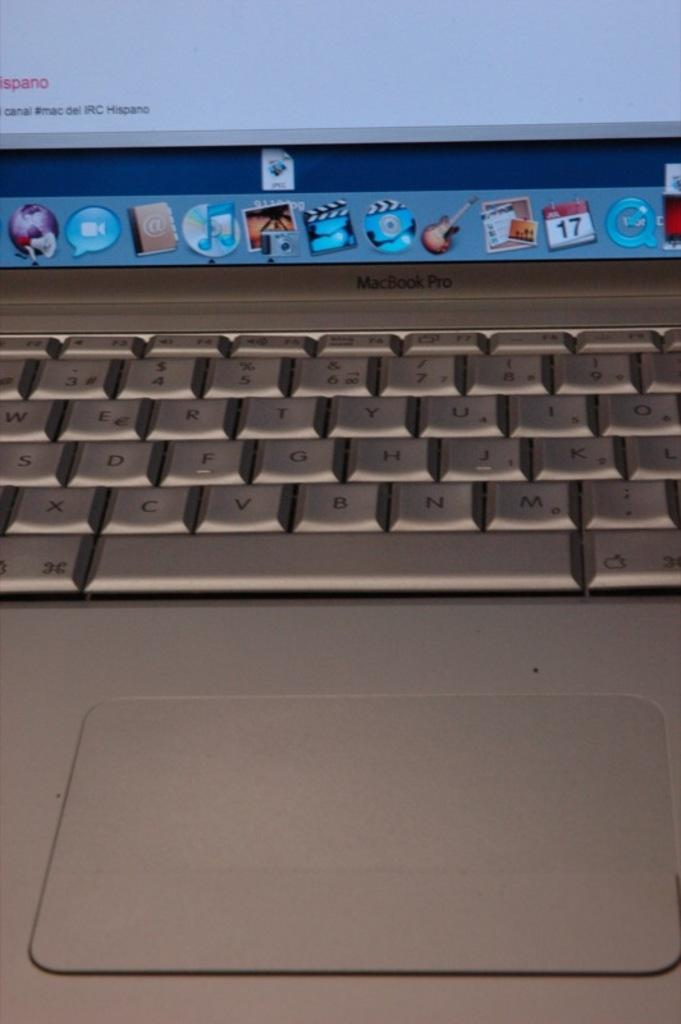<image>
Provide a brief description of the given image. a macbook pro with a turned on screen with a page open that says 'canal' 